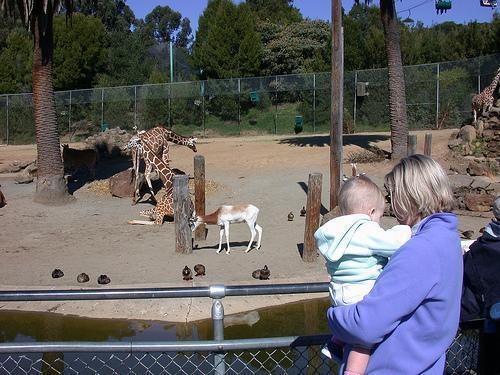How many babies are there?
Give a very brief answer. 1. 